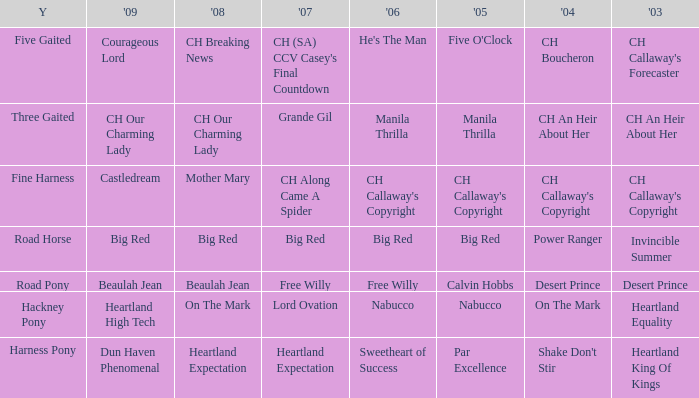What year is the 2004 shake don't stir? Harness Pony. 